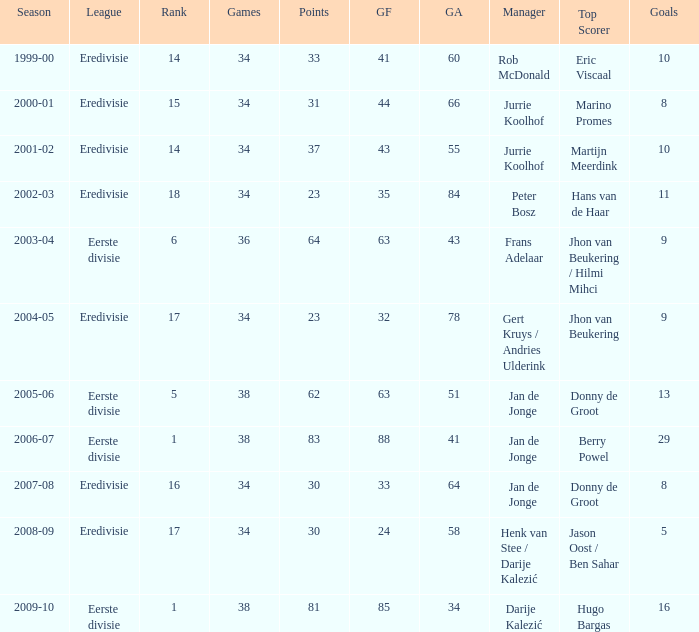What is the rank of manager Rob Mcdonald? 1.0. 